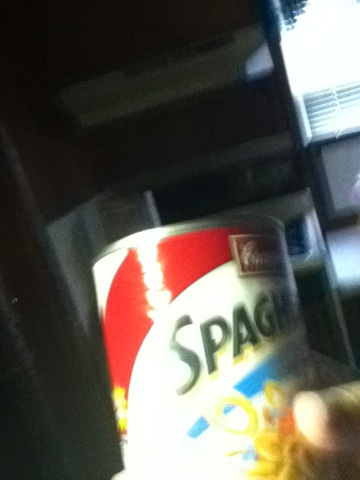How does this canned spaghetti compare to homemade spaghetti? Canned spaghetti is convenient and saves time, but there are some differences compared to homemade spaghetti. Homemade spaghetti allows you to control the ingredients, ensuring they are fresh and free of preservatives. It also offers the flexibility to modify the recipe to your taste, whether it's using whole wheat pasta, adding fresh herbs, or creating a sauce from scratch with garden tomatoes. Canned spaghetti, on the other hand, is pre-cooked and seasoned, which can cut down on preparation time and is ideal for quick meals. However, it may contain additives and might not have the sharegpt4v/same depth of flavor as a homemade dish.  Describe a realistic scenario where you might use this canned spaghetti. A realistic scenario for using canned spaghetti is on a busy weekday evening when time is limited. After a long day at work, you need to prepare a meal quickly. You can heat the canned spaghetti on the stove or in the microwave, and in minutes, you have a hot meal ready for your family. For added nutrition, you can pair it with a side salad or some steamed vegetables. Another realistic scenario please. Another scenario is during a camping trip. Canned spaghetti is a practical option since it does not require refrigeration and can be easily heated over a campfire. It's a comforting meal after a day of outdoor activities. Pair it with some crusty bread toasted over the fire, and you have a satisfying, hearty dinner under the stars. 